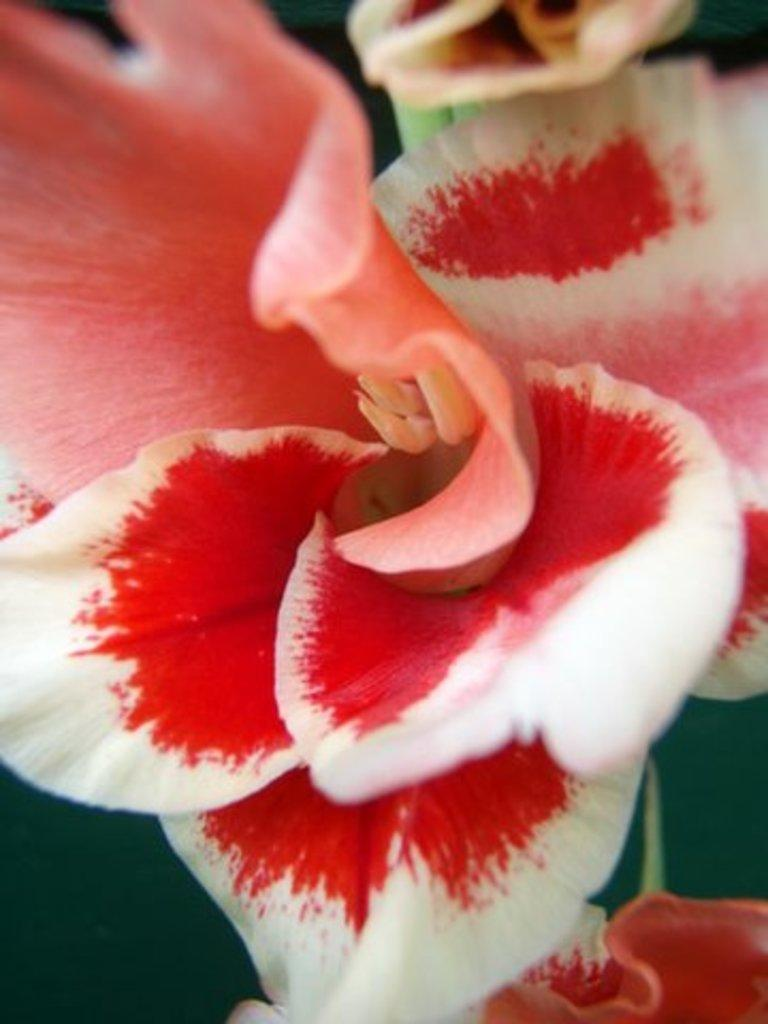What colors of flowers can be seen in the image? There are white flowers and red flowers in the image. Where is the playground located in the image? There is no playground present in the image; it only features flowers. What type of stem can be seen on the red flowers in the image? The image does not show the stems of the flowers, only the petals of the white and red flowers. 